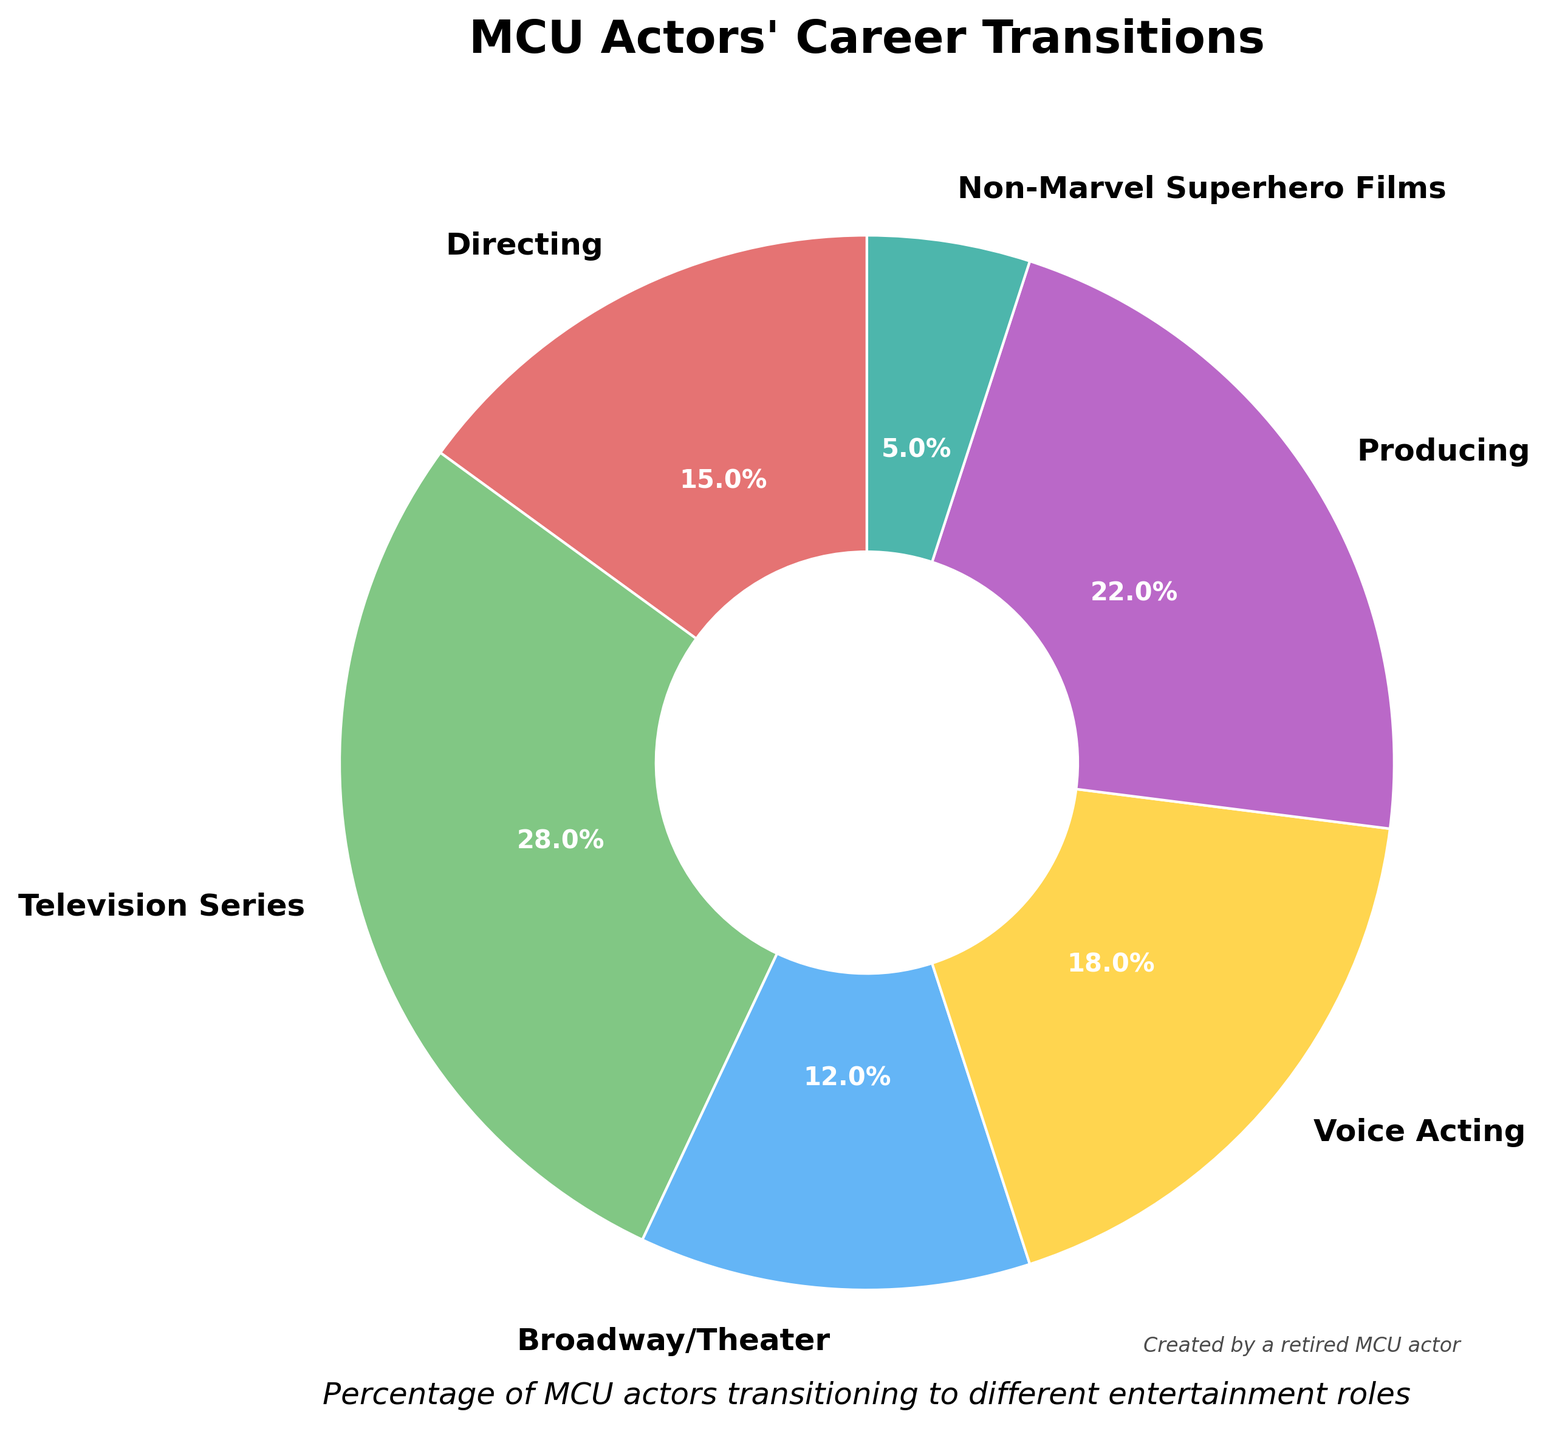What category has the highest percentage of MCU actors transitioning into it? By looking at the chart, the largest slice represents MCU actors transitioning into 'Television Series' roles. This slice is visually larger than the others and is labeled with the highest percentage.
Answer: Television Series What is the combined percentage of MCU actors who transitioned into Directing and Producing? To determine the combined percentage, add the percentage from 'Directing' and 'Producing'. According to the chart, 'Directing' is 15% and 'Producing' is 22%. So, 15% + 22% = 37%.
Answer: 37% Which category has the smallest slice and what is its percentage? The smallest slice of the pie chart represents 'Non-Marvel Superhero Films'. By looking at the chart, we can see that this slice is the smallest compared to others and it's labeled as 5%.
Answer: Non-Marvel Superhero Films, 5% How does the percentage of actors transitioning to Broadway/Theater compare to those transitioning to Voice Acting? Look at the slices representing 'Broadway/Theater' and 'Voice Acting'. 'Broadway/Theater' represents 12% while 'Voice Acting' accounts for 18%. Therefore, more actors transitioned to Voice Acting than to Broadway/Theater.
Answer: Voice Acting is higher What's the difference in percentage between actors transitioning to Producing and Directing? Referring to the chart, 'Producing' is 22% and 'Directing' is 15%. The difference is calculated by subtracting the percentage of Directing from Producing: 22% - 15% = 7%.
Answer: 7% Which entertainment role has a higher percentage: Broadway/Theater or Non-Marvel Superhero Films? Compare the labeled percentages of 'Broadway/Theater' and 'Non-Marvel Superhero Films' slices. 'Broadway/Theater' is 12% and 'Non-Marvel Superhero Films' is 5%. Therefore, 'Broadway/Theater' is higher.
Answer: Broadway/Theater What is the sum of the percentages of categories with a higher percentage than 20%? Determine the categories with more than 20%: 'Television Series' (28%) and 'Producing' (22%). Sum these percentages: 28% + 22% = 50%.
Answer: 50% What color represents the category with the second highest percentage? Look at the slices. The second-largest slice represents 'Producing' and its color is a shade of green.
Answer: Green Is the percentage of MCU actors transitioning to Voice Acting more than twice the percentage transitioning to Non-Marvel Superhero Films? Voice Acting is 18% and Non-Marvel Superhero Films is 5%. Twice the percentage of Non-Marvel Superhero Films is 10% (2*5%=10%). Since 18% is greater than 10%, the percentage of Voice Acting is more than twice of Non-Marvel Superhero Films.
Answer: Yes Which categories combined give exactly half of the pie chart? Calculate the sum of 'Directing', 'Broadway/Theater', and 'Non-Marvel Superhero Films'. Their percentages are 15%, 12%, and 5% respectively. Adding these: 15% + 12% + 5% = 32%. Now, 'Television Series' is 28%, so combining 'Television Series' and 'Voice Acting' also covers this: 28% + 18% = 46% which does not work. Correct combination is 'Directing', 'Television Series', 'Voice Acting': 15% + 28% + 18% = 61%. Correct one is Producing 22%, Broadway/Theater 12%, Non-Marvel Superhero Films 5%, adding Directing: 22%+12%+5%+15% = 54%. Answer: Producing, Broadway/Theater, Non-Marvel Superhero Films
Answer: Producing, Broadway/Theater, Non-Marvel Superhero Films, Directing 